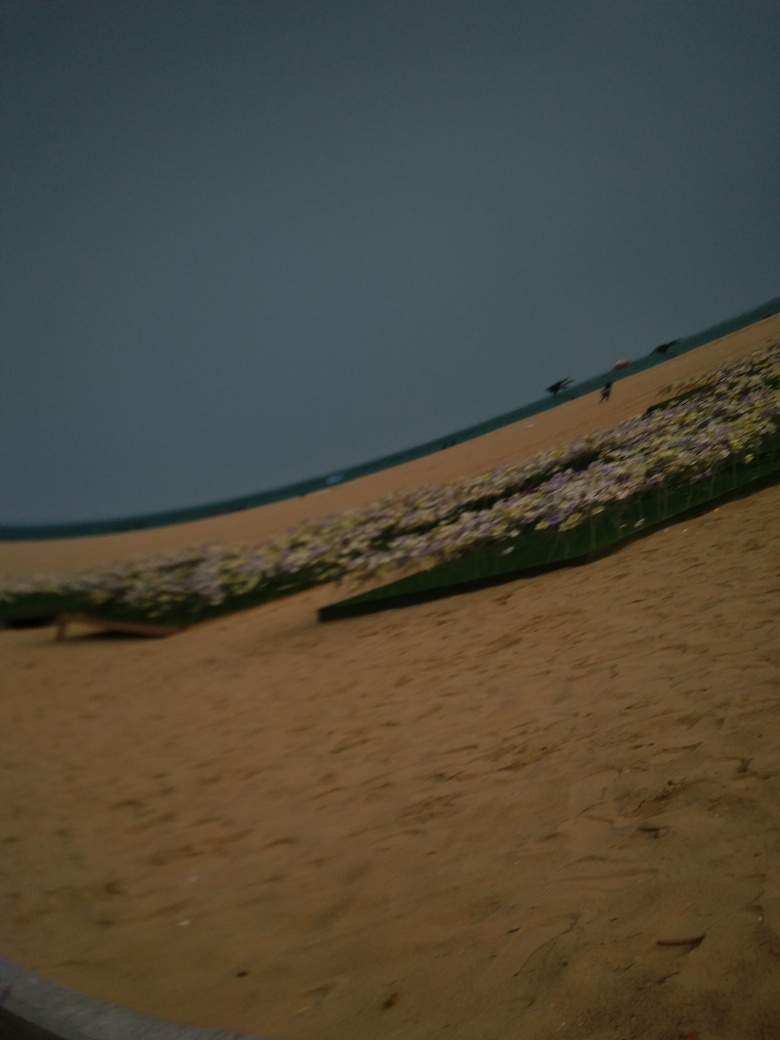Is the overall clarity of the image high? The clarity of the image is poor, which may be due to several factors such as motion blur, low lighting conditions, or a camera not focused properly. This can make it challenging to discern fine details within the scene, such as the specific types of flowers or clarity of the skyline. 